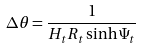Convert formula to latex. <formula><loc_0><loc_0><loc_500><loc_500>\Delta \theta = \frac { 1 } { H _ { t } R _ { t } \sinh \Psi _ { t } }</formula> 